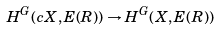<formula> <loc_0><loc_0><loc_500><loc_500>H ^ { G } ( c X , E ( R ) ) \to H ^ { G } ( X , E ( R ) )</formula> 